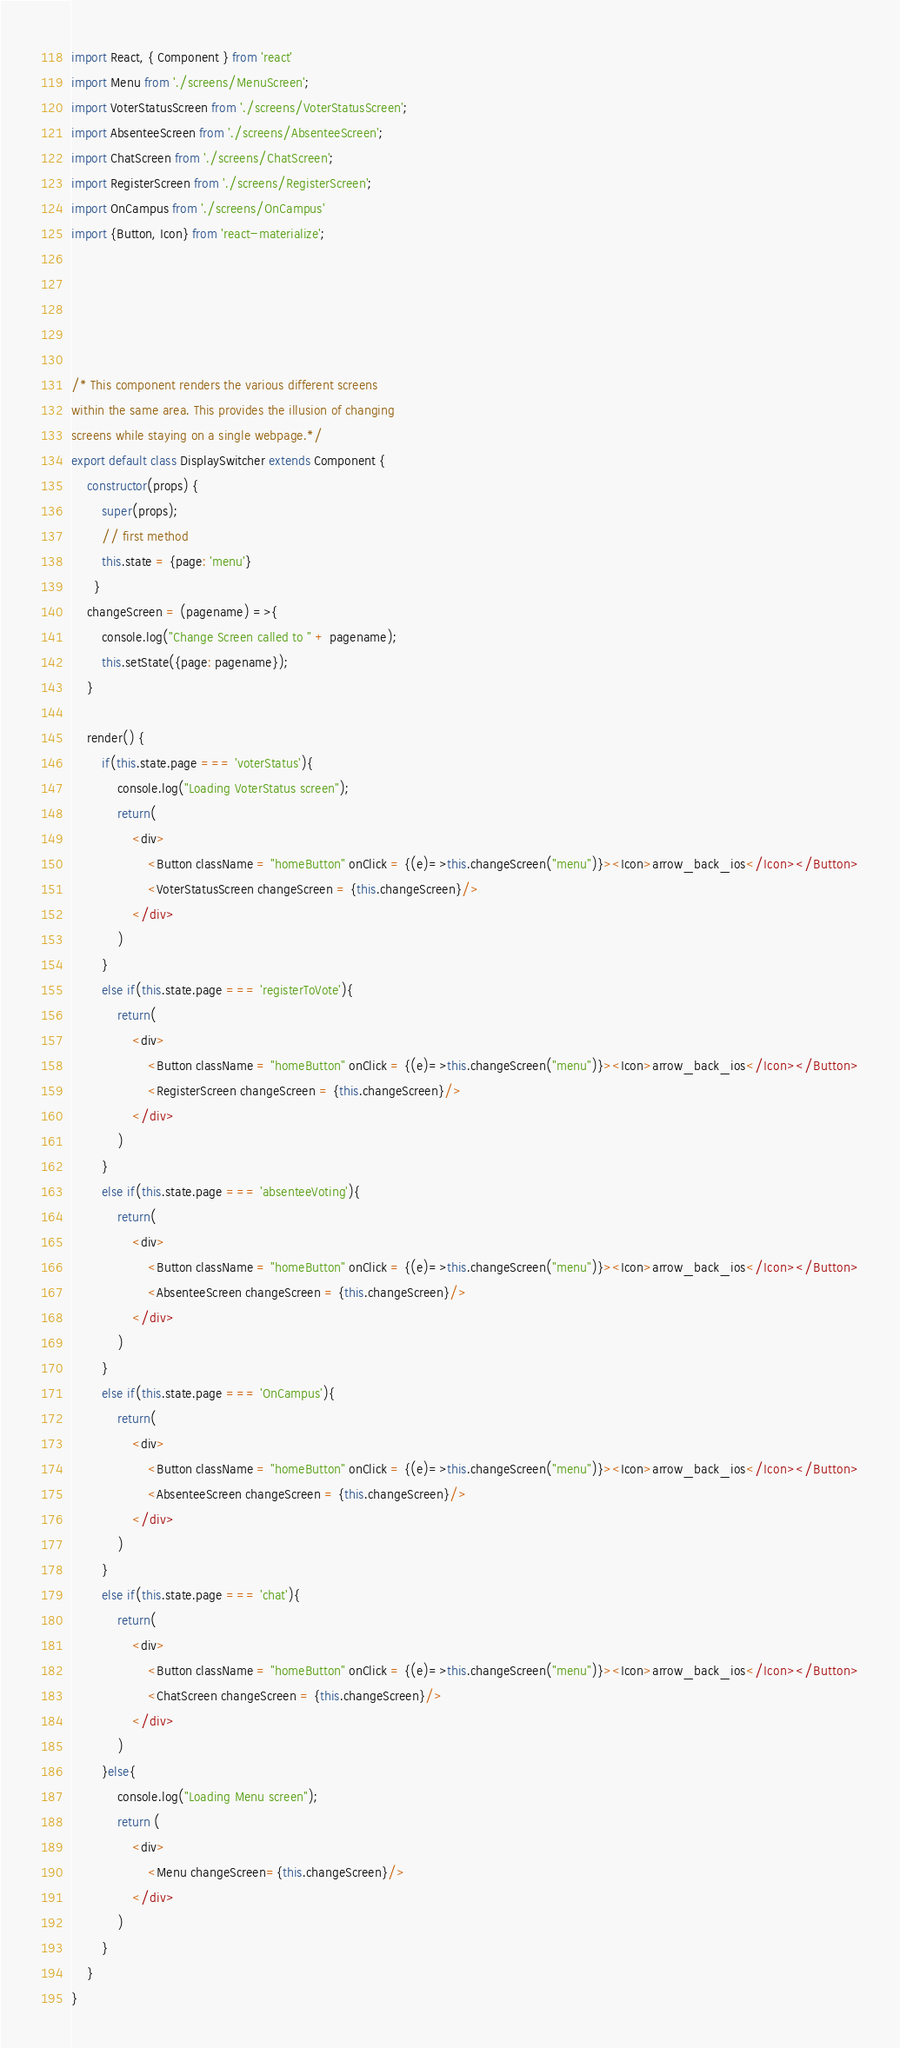<code> <loc_0><loc_0><loc_500><loc_500><_JavaScript_>import React, { Component } from 'react'
import Menu from './screens/MenuScreen';
import VoterStatusScreen from './screens/VoterStatusScreen';
import AbsenteeScreen from './screens/AbsenteeScreen';
import ChatScreen from './screens/ChatScreen';
import RegisterScreen from './screens/RegisterScreen';
import OnCampus from './screens/OnCampus'
import {Button, Icon} from 'react-materialize';





/* This component renders the various different screens 
within the same area. This provides the illusion of changing 
screens while staying on a single webpage.*/
export default class DisplaySwitcher extends Component {
    constructor(props) {
        super(props);
        // first method
        this.state = {page: 'menu'}
      }
    changeScreen = (pagename) =>{
        console.log("Change Screen called to " + pagename);
        this.setState({page: pagename});
    }

    render() {
        if(this.state.page === 'voterStatus'){
            console.log("Loading VoterStatus screen");
            return(
                <div>
                    <Button className = "homeButton" onClick = {(e)=>this.changeScreen("menu")}><Icon>arrow_back_ios</Icon></Button>
                    <VoterStatusScreen changeScreen = {this.changeScreen}/>
                </div>
            )
        }
        else if(this.state.page === 'registerToVote'){
            return(
                <div>
                    <Button className = "homeButton" onClick = {(e)=>this.changeScreen("menu")}><Icon>arrow_back_ios</Icon></Button>
                    <RegisterScreen changeScreen = {this.changeScreen}/>
                </div>
            )
        }
        else if(this.state.page === 'absenteeVoting'){
            return(
                <div>
                    <Button className = "homeButton" onClick = {(e)=>this.changeScreen("menu")}><Icon>arrow_back_ios</Icon></Button>
                    <AbsenteeScreen changeScreen = {this.changeScreen}/>
                </div>
            )
        }
        else if(this.state.page === 'OnCampus'){
            return(
                <div>
                    <Button className = "homeButton" onClick = {(e)=>this.changeScreen("menu")}><Icon>arrow_back_ios</Icon></Button>
                    <AbsenteeScreen changeScreen = {this.changeScreen}/>
                </div>
            )
        }
        else if(this.state.page === 'chat'){
            return(
                <div>
                    <Button className = "homeButton" onClick = {(e)=>this.changeScreen("menu")}><Icon>arrow_back_ios</Icon></Button>
                    <ChatScreen changeScreen = {this.changeScreen}/>
                </div>
            )
        }else{
            console.log("Loading Menu screen");
            return (
                <div>
                    <Menu changeScreen={this.changeScreen}/>
                </div>
            )
        }
    }
}
</code> 